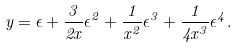<formula> <loc_0><loc_0><loc_500><loc_500>y = \epsilon + \frac { 3 } { 2 x } \epsilon ^ { 2 } + \frac { 1 } { x ^ { 2 } } \epsilon ^ { 3 } + \frac { 1 } { 4 x ^ { 3 } } \epsilon ^ { 4 } .</formula> 